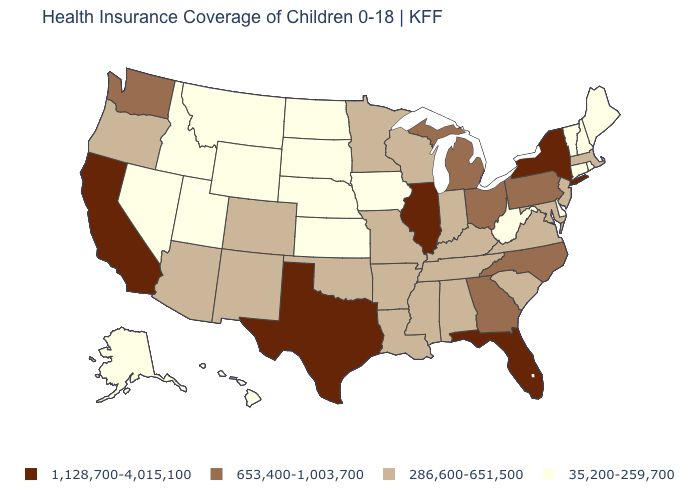Does Texas have the highest value in the USA?
Keep it brief. Yes. Does Alaska have the lowest value in the USA?
Quick response, please. Yes. Does the first symbol in the legend represent the smallest category?
Answer briefly. No. What is the value of New Jersey?
Keep it brief. 286,600-651,500. Name the states that have a value in the range 286,600-651,500?
Answer briefly. Alabama, Arizona, Arkansas, Colorado, Indiana, Kentucky, Louisiana, Maryland, Massachusetts, Minnesota, Mississippi, Missouri, New Jersey, New Mexico, Oklahoma, Oregon, South Carolina, Tennessee, Virginia, Wisconsin. Among the states that border Louisiana , which have the lowest value?
Keep it brief. Arkansas, Mississippi. What is the value of Mississippi?
Quick response, please. 286,600-651,500. Name the states that have a value in the range 653,400-1,003,700?
Write a very short answer. Georgia, Michigan, North Carolina, Ohio, Pennsylvania, Washington. What is the value of Nevada?
Quick response, please. 35,200-259,700. What is the value of North Dakota?
Short answer required. 35,200-259,700. How many symbols are there in the legend?
Keep it brief. 4. Does the map have missing data?
Keep it brief. No. Among the states that border Nevada , which have the lowest value?
Write a very short answer. Idaho, Utah. Among the states that border Wisconsin , does Iowa have the lowest value?
Concise answer only. Yes. What is the value of New Mexico?
Keep it brief. 286,600-651,500. 